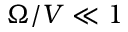<formula> <loc_0><loc_0><loc_500><loc_500>\Omega / V \ll 1</formula> 